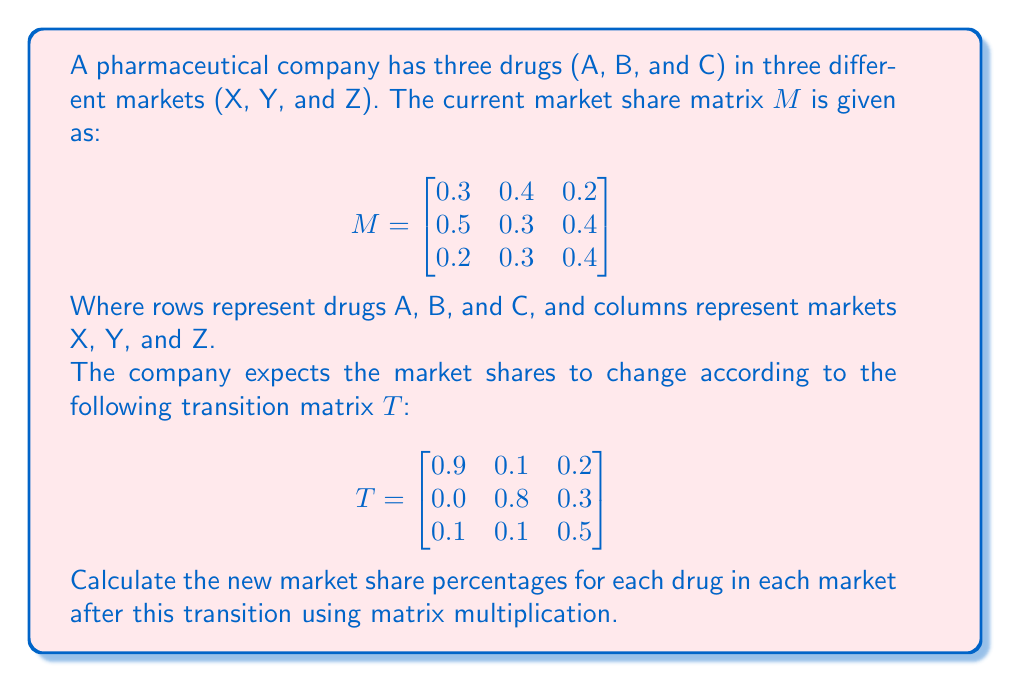Give your solution to this math problem. To calculate the new market share percentages, we need to multiply the current market share matrix $M$ by the transition matrix $T$. This operation is performed as follows:

1) The resulting matrix will have the same dimensions as $M$ (3x3).

2) We calculate each element of the new matrix using the dot product of a row from $M$ and a column from $T$.

3) Let's call the new market share matrix $N$. Then:

   $$N = M \times T$$

4) Performing the matrix multiplication:

   $$\begin{bmatrix}
   0.3 & 0.4 & 0.2 \\
   0.5 & 0.3 & 0.4 \\
   0.2 & 0.3 & 0.4
   \end{bmatrix} \times 
   \begin{bmatrix}
   0.9 & 0.1 & 0.2 \\
   0.0 & 0.8 & 0.3 \\
   0.1 & 0.1 & 0.5
   \end{bmatrix}$$

5) Calculating each element:

   $N_{11} = 0.3(0.9) + 0.4(0.0) + 0.2(0.1) = 0.29$
   $N_{12} = 0.3(0.1) + 0.4(0.8) + 0.2(0.1) = 0.37$
   $N_{13} = 0.3(0.2) + 0.4(0.3) + 0.2(0.5) = 0.28$

   $N_{21} = 0.5(0.9) + 0.3(0.0) + 0.4(0.1) = 0.49$
   $N_{22} = 0.5(0.1) + 0.3(0.8) + 0.4(0.1) = 0.33$
   $N_{23} = 0.5(0.2) + 0.3(0.3) + 0.4(0.5) = 0.39$

   $N_{31} = 0.2(0.9) + 0.3(0.0) + 0.4(0.1) = 0.22$
   $N_{32} = 0.2(0.1) + 0.3(0.8) + 0.4(0.1) = 0.30$
   $N_{33} = 0.2(0.2) + 0.3(0.3) + 0.4(0.5) = 0.33$

6) Therefore, the new market share matrix is:

   $$N = \begin{bmatrix}
   0.29 & 0.37 & 0.28 \\
   0.49 & 0.33 & 0.39 \\
   0.22 & 0.30 & 0.33
   \end{bmatrix}$$

This matrix represents the new market share percentages for each drug in each market after the transition.
Answer: $$\begin{bmatrix}
0.29 & 0.37 & 0.28 \\
0.49 & 0.33 & 0.39 \\
0.22 & 0.30 & 0.33
\end{bmatrix}$$ 